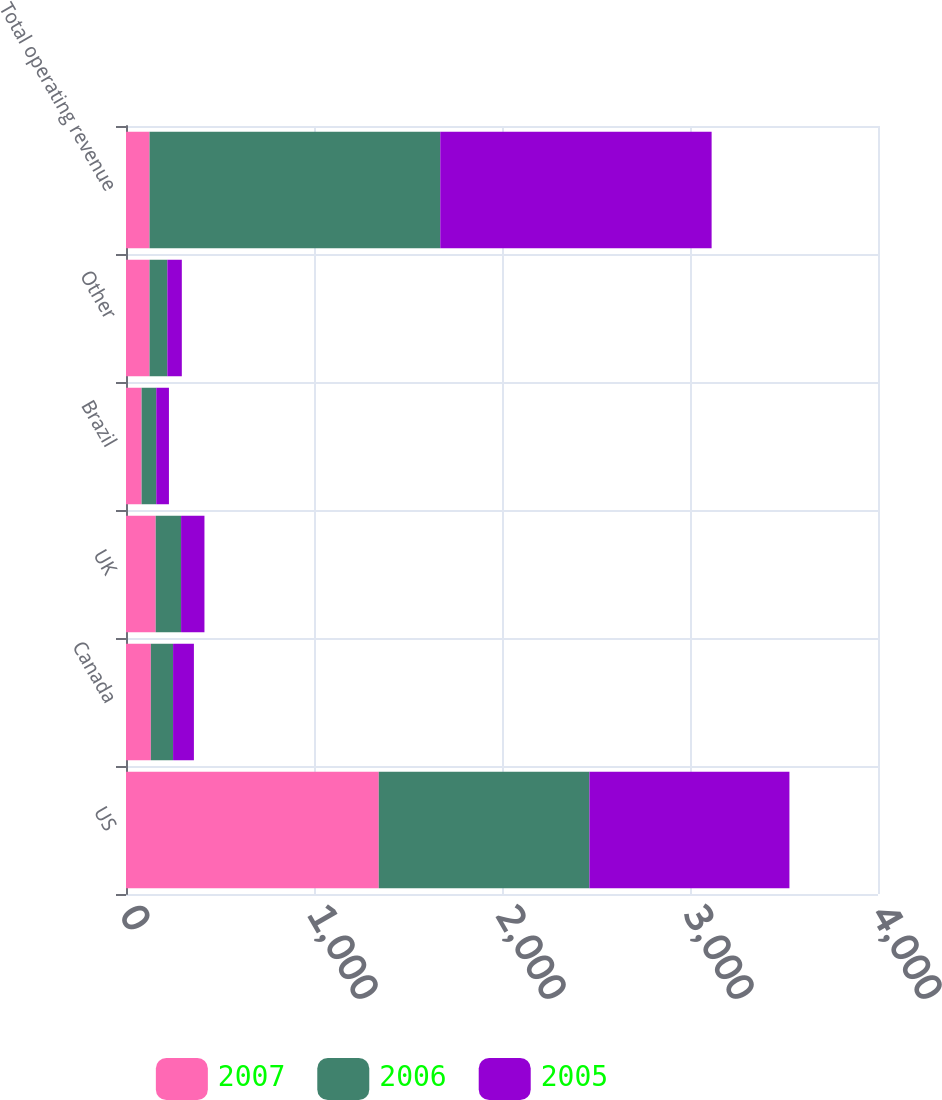Convert chart. <chart><loc_0><loc_0><loc_500><loc_500><stacked_bar_chart><ecel><fcel>US<fcel>Canada<fcel>UK<fcel>Brazil<fcel>Other<fcel>Total operating revenue<nl><fcel>2007<fcel>1344.5<fcel>132.2<fcel>158<fcel>83<fcel>125.3<fcel>125.3<nl><fcel>2006<fcel>1120.5<fcel>118.2<fcel>135<fcel>78<fcel>94.6<fcel>1546.3<nl><fcel>2005<fcel>1063.9<fcel>110.8<fcel>124.3<fcel>67.4<fcel>77<fcel>1443.4<nl></chart> 